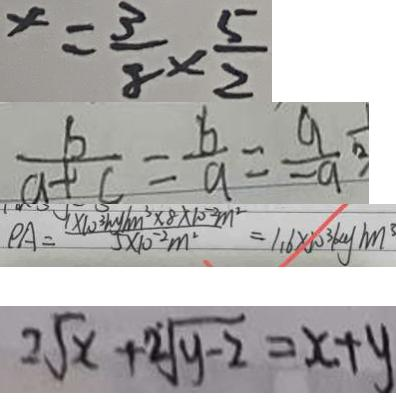<formula> <loc_0><loc_0><loc_500><loc_500>x = \frac { 3 } { 8 } \times \frac { 5 } { 2 } 
 \frac { b } { a + c } = \frac { b } { a } = \frac { a } { - a } 
 P A = \frac { 1 \times 1 0 ^ { 3 } k g / m ^ { 3 } \times 8 \times 1 0 ^ { - 2 } m ^ { 2 } } { 5 \times 1 0 ^ { - 2 } m ^ { 2 } } = 1 . 6 \times 1 0 ^ { 3 } k g / m ^ { 3 } 
 2 \sqrt { x } + 2 \sqrt { y - 2 } = x + y</formula> 